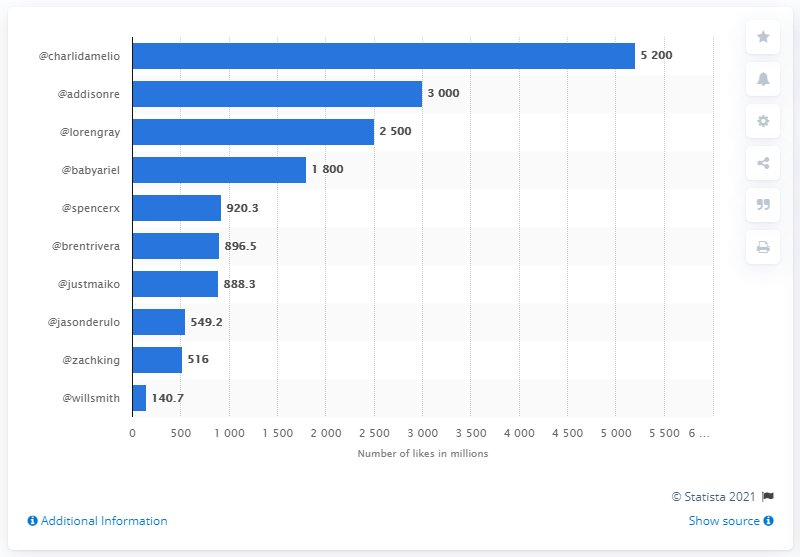What details can you provide about the source of this data? The data in this chart is sourced from Statista, a reputable company specializing in market and consumer data, as indicated by the watermark on the bottom right of the image. The specific year or time range is not mentioned, hence it's important to note that the likes count may have changed since this data was published in 2021. 